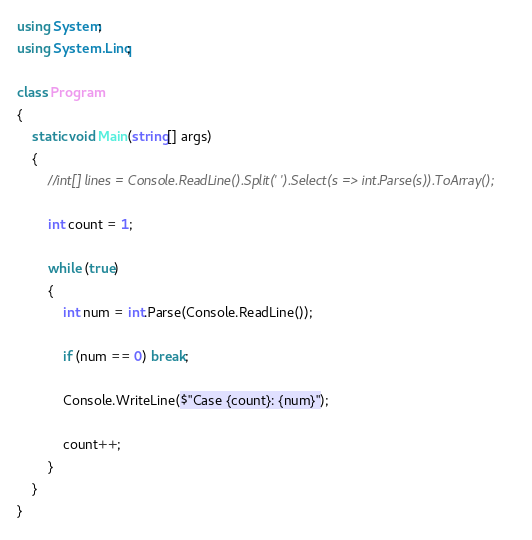Convert code to text. <code><loc_0><loc_0><loc_500><loc_500><_C#_>using System;
using System.Linq;

class Program
{
    static void Main(string[] args)
    {
        //int[] lines = Console.ReadLine().Split(' ').Select(s => int.Parse(s)).ToArray();

        int count = 1;

        while (true)
        {
            int num = int.Parse(Console.ReadLine());

            if (num == 0) break;

            Console.WriteLine($"Case {count}: {num}");

            count++;
        }
    }
}</code> 